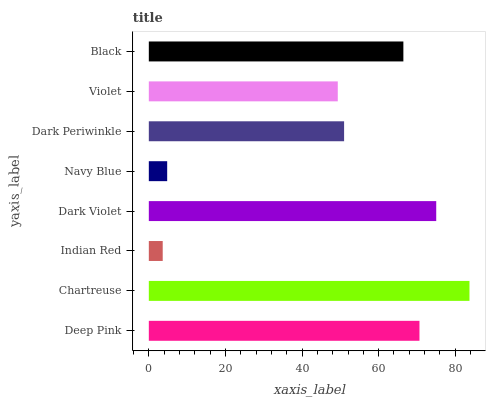Is Indian Red the minimum?
Answer yes or no. Yes. Is Chartreuse the maximum?
Answer yes or no. Yes. Is Chartreuse the minimum?
Answer yes or no. No. Is Indian Red the maximum?
Answer yes or no. No. Is Chartreuse greater than Indian Red?
Answer yes or no. Yes. Is Indian Red less than Chartreuse?
Answer yes or no. Yes. Is Indian Red greater than Chartreuse?
Answer yes or no. No. Is Chartreuse less than Indian Red?
Answer yes or no. No. Is Black the high median?
Answer yes or no. Yes. Is Dark Periwinkle the low median?
Answer yes or no. Yes. Is Navy Blue the high median?
Answer yes or no. No. Is Dark Violet the low median?
Answer yes or no. No. 